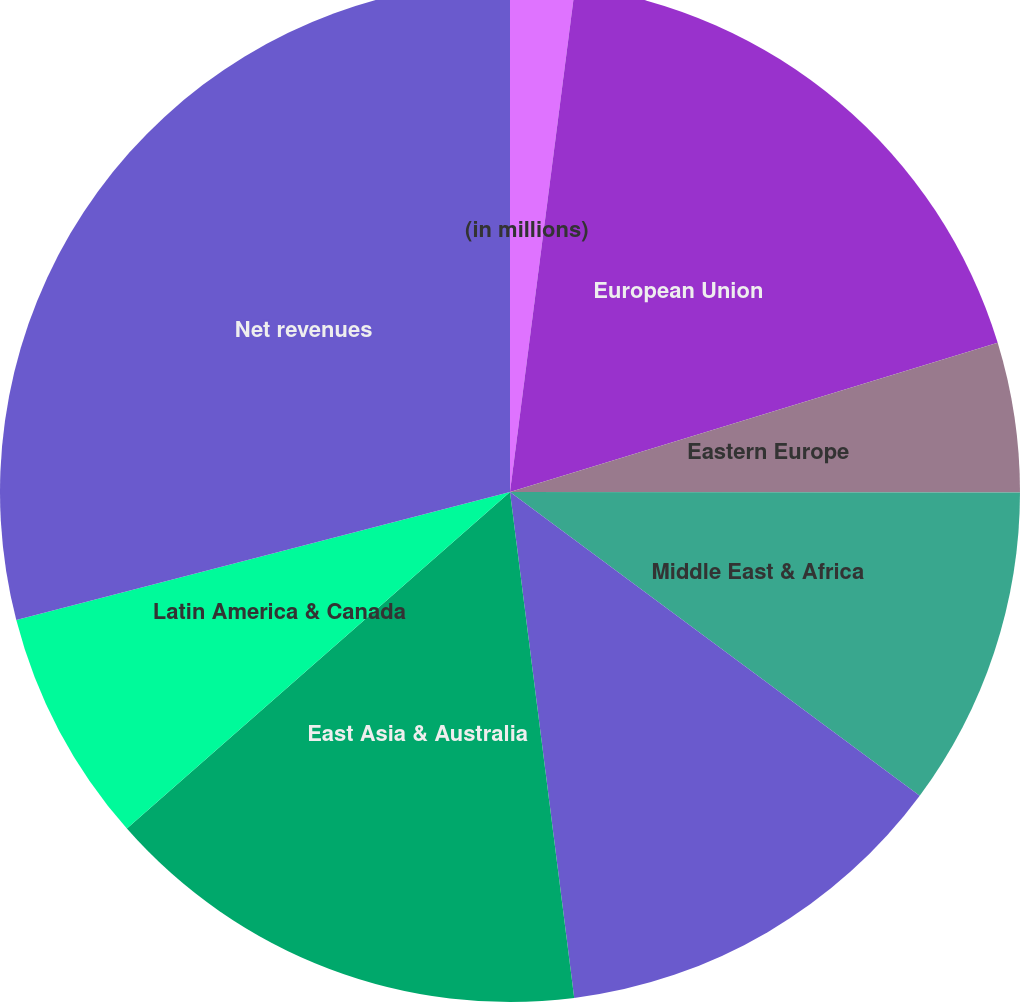Convert chart. <chart><loc_0><loc_0><loc_500><loc_500><pie_chart><fcel>(in millions)<fcel>European Union<fcel>Eastern Europe<fcel>Middle East & Africa<fcel>South & Southeast Asia<fcel>East Asia & Australia<fcel>Latin America & Canada<fcel>Net revenues<nl><fcel>2.04%<fcel>18.24%<fcel>4.74%<fcel>10.14%<fcel>12.84%<fcel>15.54%<fcel>7.44%<fcel>29.04%<nl></chart> 